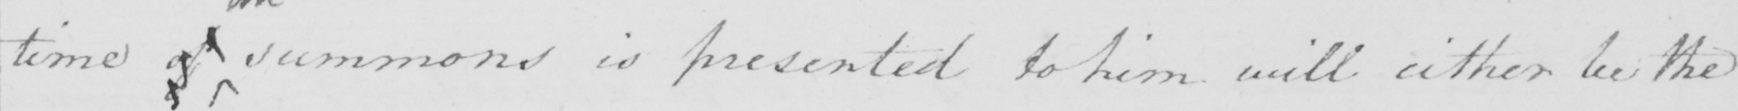Can you read and transcribe this handwriting? time of summons is presented to him will either be the 